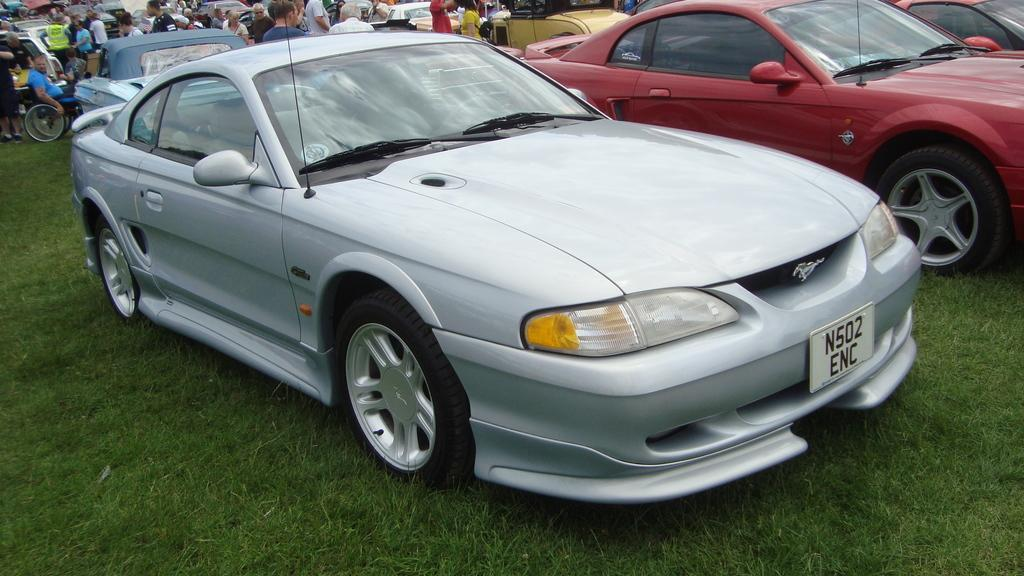What types of objects can be seen in the image? There are vehicles in the image. What are the people in the image doing? The people are standing on the grass in the image. What type of vegetation is visible in the image? The grass is visible in the image. How many grains of sand can be seen in the image? There is no sand present in the image, so it is not possible to determine the number of grains of sand. 